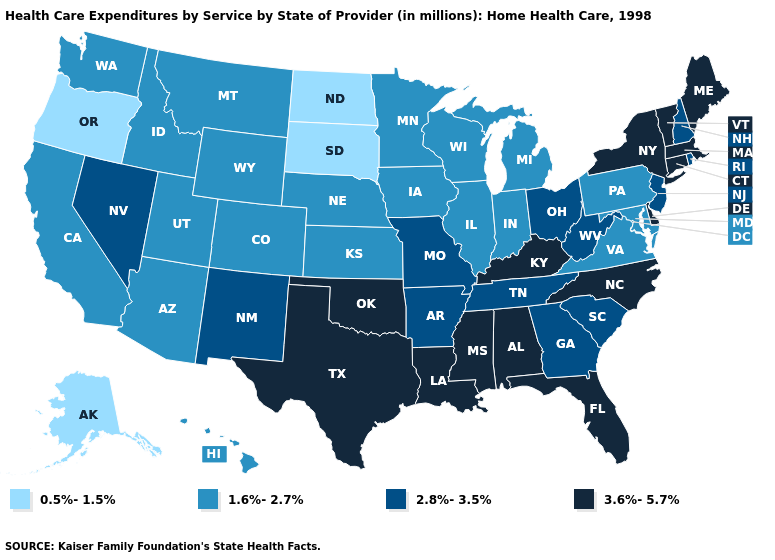What is the value of Idaho?
Answer briefly. 1.6%-2.7%. Does the first symbol in the legend represent the smallest category?
Be succinct. Yes. Name the states that have a value in the range 1.6%-2.7%?
Concise answer only. Arizona, California, Colorado, Hawaii, Idaho, Illinois, Indiana, Iowa, Kansas, Maryland, Michigan, Minnesota, Montana, Nebraska, Pennsylvania, Utah, Virginia, Washington, Wisconsin, Wyoming. Which states have the highest value in the USA?
Short answer required. Alabama, Connecticut, Delaware, Florida, Kentucky, Louisiana, Maine, Massachusetts, Mississippi, New York, North Carolina, Oklahoma, Texas, Vermont. What is the value of Maine?
Be succinct. 3.6%-5.7%. How many symbols are there in the legend?
Keep it brief. 4. What is the value of Virginia?
Write a very short answer. 1.6%-2.7%. Among the states that border Iowa , does South Dakota have the lowest value?
Be succinct. Yes. Which states have the lowest value in the USA?
Concise answer only. Alaska, North Dakota, Oregon, South Dakota. What is the value of Massachusetts?
Write a very short answer. 3.6%-5.7%. Does Oregon have a lower value than South Dakota?
Quick response, please. No. Among the states that border North Dakota , does South Dakota have the highest value?
Short answer required. No. What is the value of Massachusetts?
Short answer required. 3.6%-5.7%. What is the highest value in the USA?
Answer briefly. 3.6%-5.7%. Name the states that have a value in the range 0.5%-1.5%?
Keep it brief. Alaska, North Dakota, Oregon, South Dakota. 